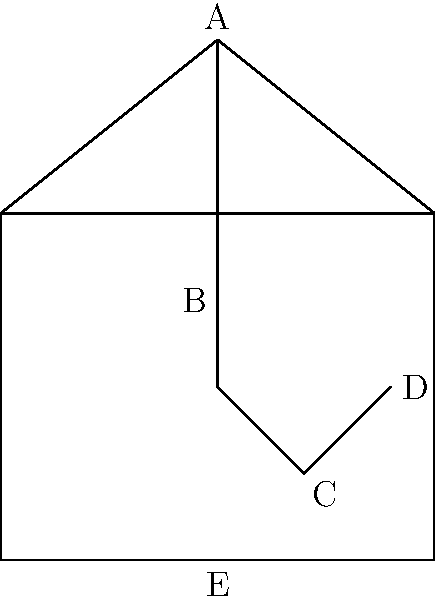In the diagram of a trebuchet, which component is responsible for providing the counterweight force and is typically labeled "C"? To answer this question, let's analyze the components of the trebuchet:

1. Part A: This is the top of the throwing arm, also known as the beam or lever arm.
2. Part B: This is the main vertical support of the throwing arm, called the upright or frame.
3. Part C: This is a box-like structure at the short end of the throwing arm.
4. Part D: This appears to be the sling or pouch that holds the projectile.
5. Part E: This is the base or platform of the trebuchet.

The key to a trebuchet's power is its use of gravitational force to launch projectiles. The component responsible for providing this force is the counterweight, which is typically a heavy box filled with stones, sand, or other dense materials.

In this diagram, the box-like structure labeled "C" is positioned at the short end of the throwing arm. This is the characteristic location for a trebuchet's counterweight. When the trebuchet is fired, this counterweight falls, using gravity to swing the long end of the throwing arm upward with great force, launching the projectile.

Therefore, the component labeled "C" in this diagram is the counterweight.
Answer: Counterweight 